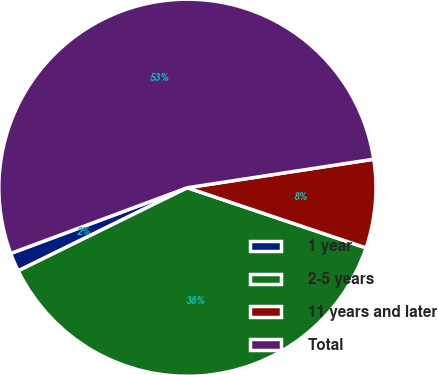Convert chart to OTSL. <chart><loc_0><loc_0><loc_500><loc_500><pie_chart><fcel>1 year<fcel>2-5 years<fcel>11 years and later<fcel>Total<nl><fcel>1.6%<fcel>37.56%<fcel>7.59%<fcel>53.25%<nl></chart> 